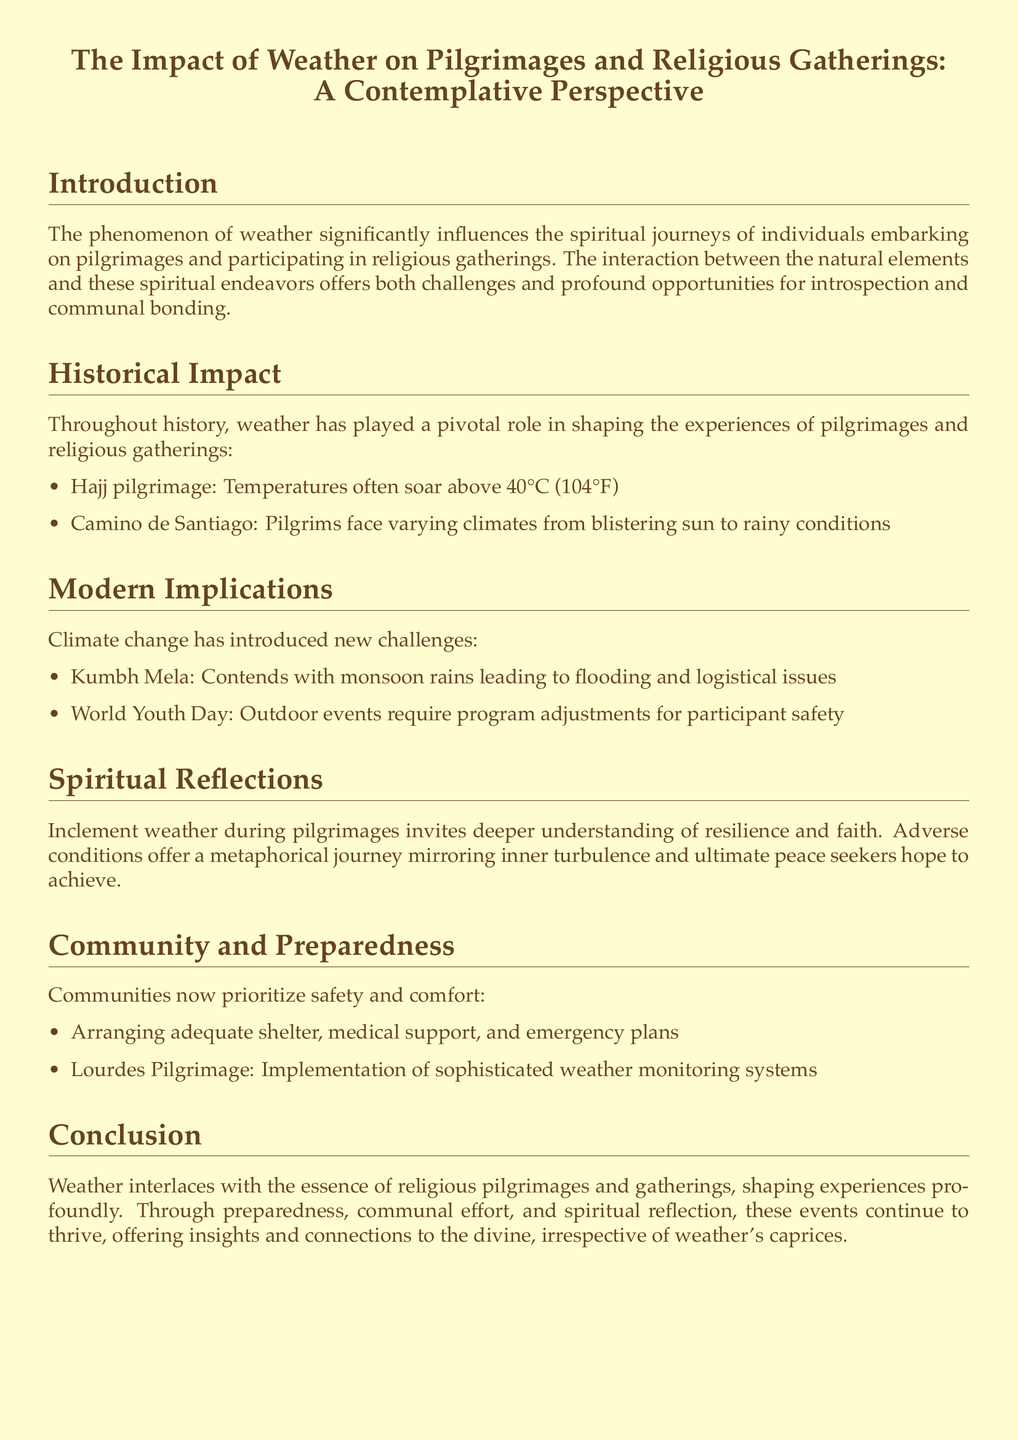what temperature do pilgrims face during the Hajj pilgrimage? The document states that temperatures often soar above 40°C (104°F) during the Hajj pilgrimage.
Answer: 40°C (104°F) what challenges does the Kumbh Mela face? The document mentions that the Kumbh Mela contends with monsoon rains leading to flooding and logistical issues.
Answer: Monsoon rains, flooding what does inclement weather invite during pilgrimages? According to the document, inclement weather invites deeper understanding of resilience and faith.
Answer: Deeper understanding of resilience and faith which pilgrimage has implemented sophisticated weather monitoring systems? The document specifies that the Lourdes Pilgrimage has implemented sophisticated weather monitoring systems.
Answer: Lourdes Pilgrimage how does climate change affect modern religious gatherings? The document discusses that climate change introduces new challenges for modern religious gatherings, such as requiring program adjustments for participant safety during outdoor events like World Youth Day.
Answer: New challenges what is a shared aspect of weather's impact on pilgrimages? The document notes that weather shapes experiences profoundly and influences both the challenges and opportunities for introspection and communal bonding.
Answer: Shapes experiences profoundly what historical pilgrimage is mentioned with varying climates? The document lists the Camino de Santiago as having varying climates from blistering sun to rainy conditions.
Answer: Camino de Santiago what is a key theme in the conclusion of the document? The conclusion emphasizes the interconnection of weather with the essence of religious pilgrimages and gatherings.
Answer: Interconnection of weather with the essence of religious pilgrimages 